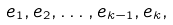<formula> <loc_0><loc_0><loc_500><loc_500>e _ { 1 } , e _ { 2 } , \dots , e _ { k - 1 } , e _ { k } ,</formula> 